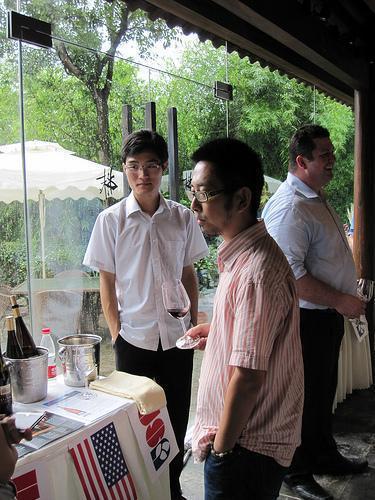How many people are pictured?
Give a very brief answer. 3. How many bottles of wine are seen?
Give a very brief answer. 2. 